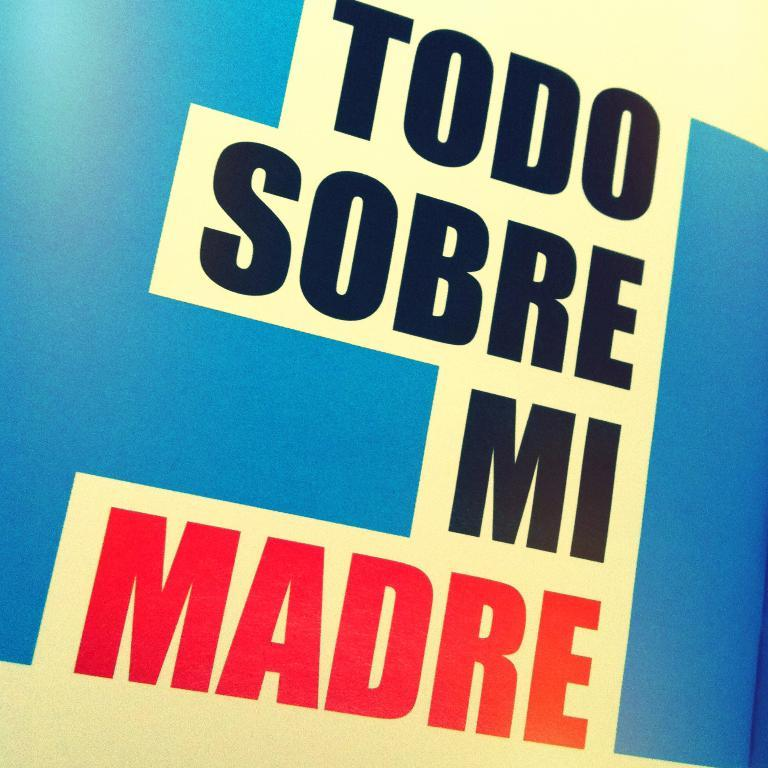<image>
Create a compact narrative representing the image presented. A poster in Spanish about a mom with a blue background. 